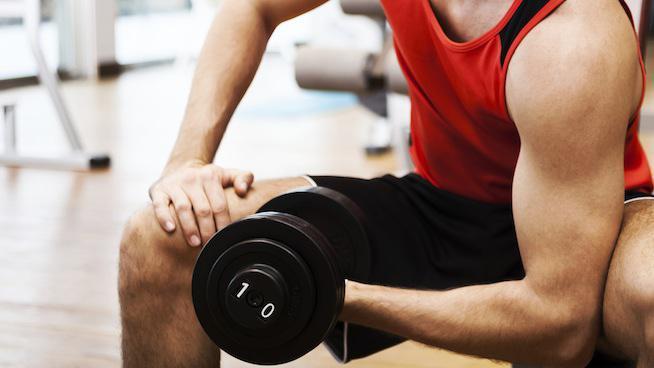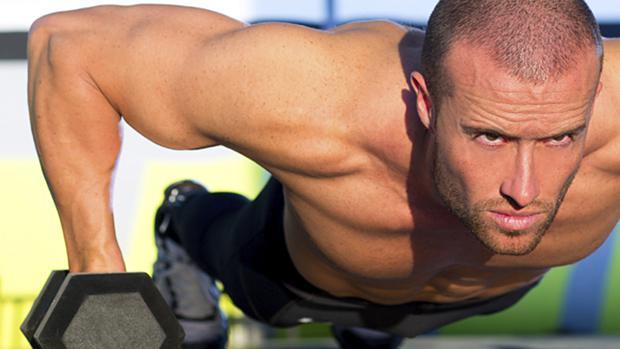The first image is the image on the left, the second image is the image on the right. For the images displayed, is the sentence "The person in the image on the left is holding one black barbell." factually correct? Answer yes or no. Yes. 